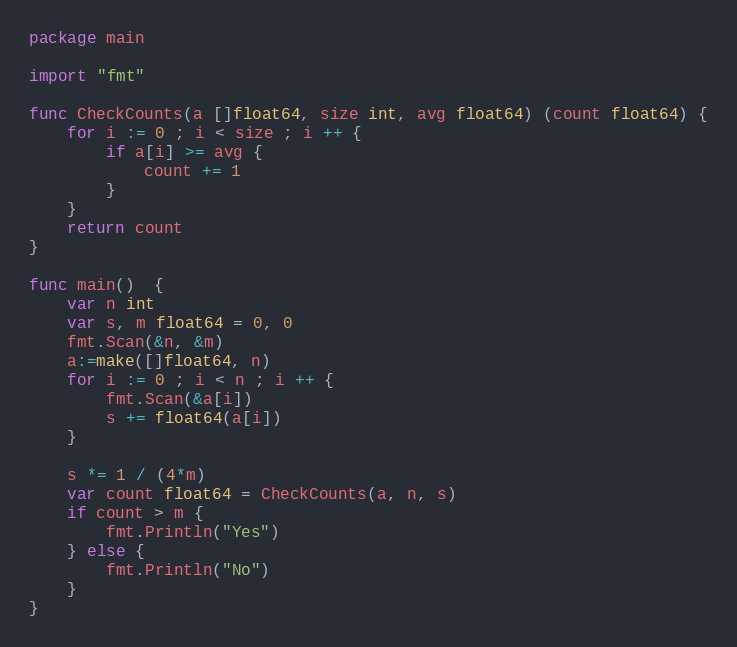Convert code to text. <code><loc_0><loc_0><loc_500><loc_500><_Go_>package main
 
import "fmt"
 
func CheckCounts(a []float64, size int, avg float64) (count float64) {
	for i := 0 ; i < size ; i ++ {
		if a[i] >= avg {
			count += 1
		}
	}
	return count
}

func main()  {
	var n int
	var s, m float64 = 0, 0
	fmt.Scan(&n, &m)
	a:=make([]float64, n)
	for i := 0 ; i < n ; i ++ {
		fmt.Scan(&a[i])
		s += float64(a[i])
	}

	s *= 1 / (4*m)
	var count float64 = CheckCounts(a, n, s)
	if count > m {
		fmt.Println("Yes")
	} else {
		fmt.Println("No")
	}
}
</code> 